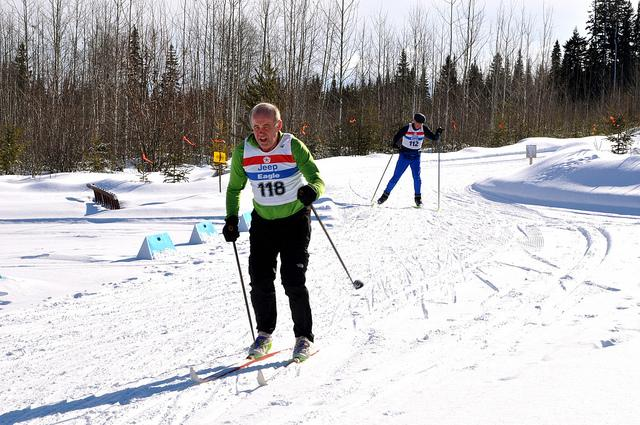What number is on the man in the green shirt's jersey? 118 